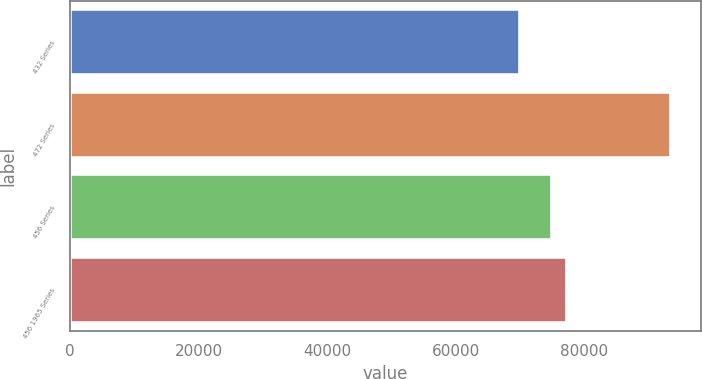Convert chart. <chart><loc_0><loc_0><loc_500><loc_500><bar_chart><fcel>432 Series<fcel>472 Series<fcel>456 Series<fcel>456 1965 Series<nl><fcel>70000<fcel>93500<fcel>75000<fcel>77350<nl></chart> 